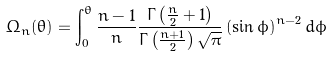Convert formula to latex. <formula><loc_0><loc_0><loc_500><loc_500>\Omega _ { n } ( \theta ) = \int _ { 0 } ^ { \theta } \frac { n - 1 } { n } \frac { \Gamma \left ( \frac { n } { 2 } + 1 \right ) } { \Gamma \left ( \frac { n + 1 } { 2 } \right ) \sqrt { \pi } } \left ( \sin \phi \right ) ^ { n - 2 } d \phi</formula> 